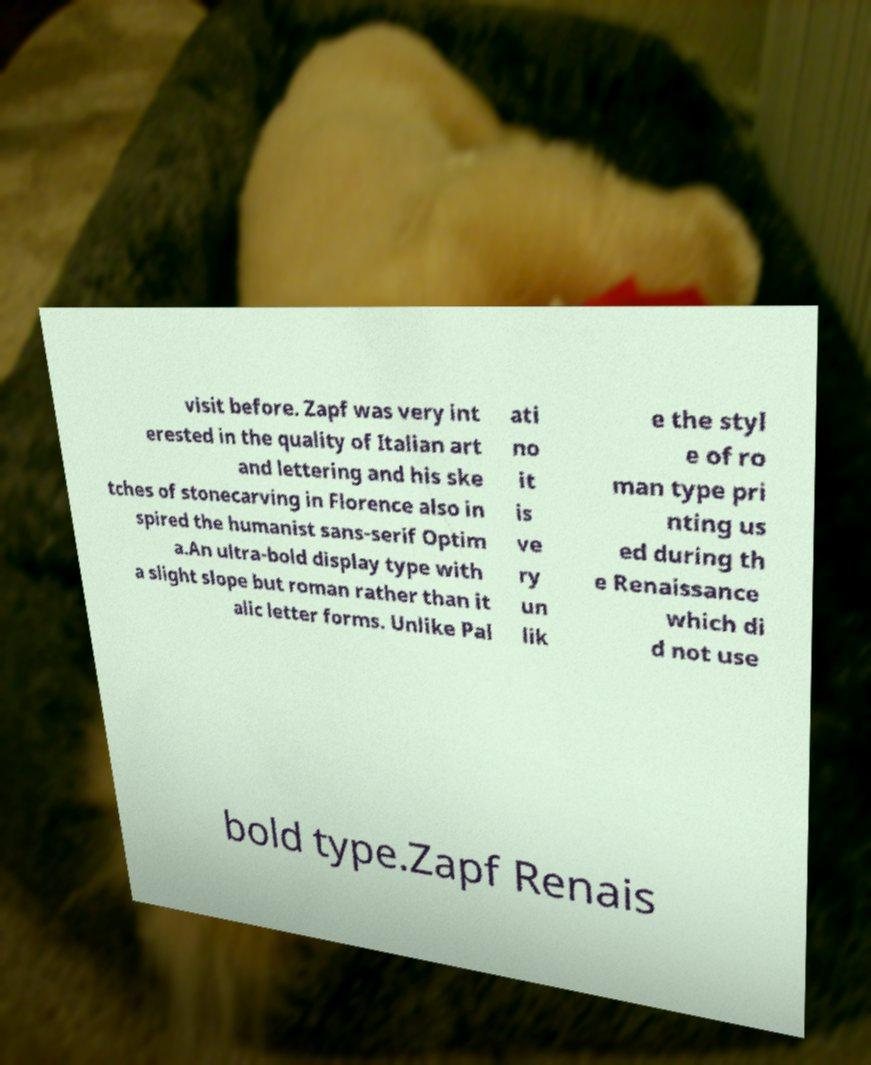Please read and relay the text visible in this image. What does it say? visit before. Zapf was very int erested in the quality of Italian art and lettering and his ske tches of stonecarving in Florence also in spired the humanist sans-serif Optim a.An ultra-bold display type with a slight slope but roman rather than it alic letter forms. Unlike Pal ati no it is ve ry un lik e the styl e of ro man type pri nting us ed during th e Renaissance which di d not use bold type.Zapf Renais 